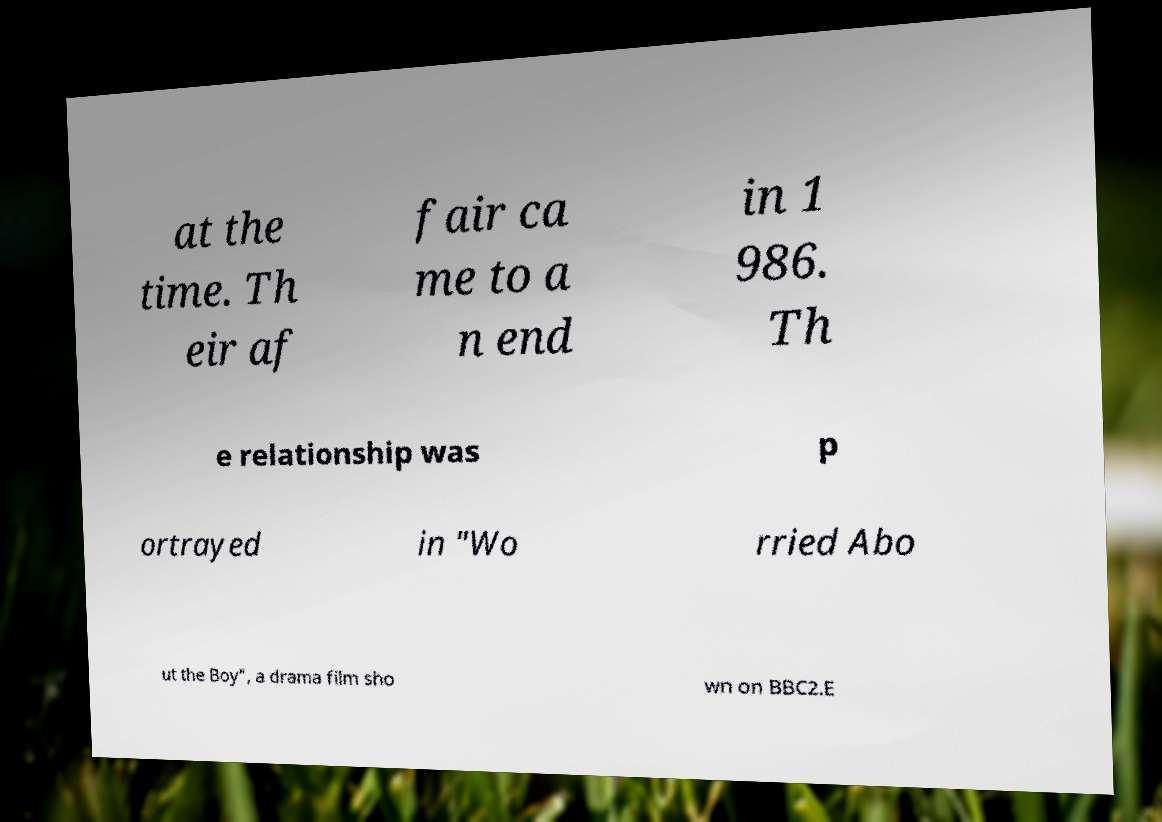Could you extract and type out the text from this image? at the time. Th eir af fair ca me to a n end in 1 986. Th e relationship was p ortrayed in "Wo rried Abo ut the Boy", a drama film sho wn on BBC2.E 